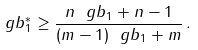Convert formula to latex. <formula><loc_0><loc_0><loc_500><loc_500>\ g b _ { 1 } ^ { \ast } \geq \frac { n \ g b _ { 1 } + n - 1 } { ( m - 1 ) \ g b _ { 1 } + m } \, .</formula> 